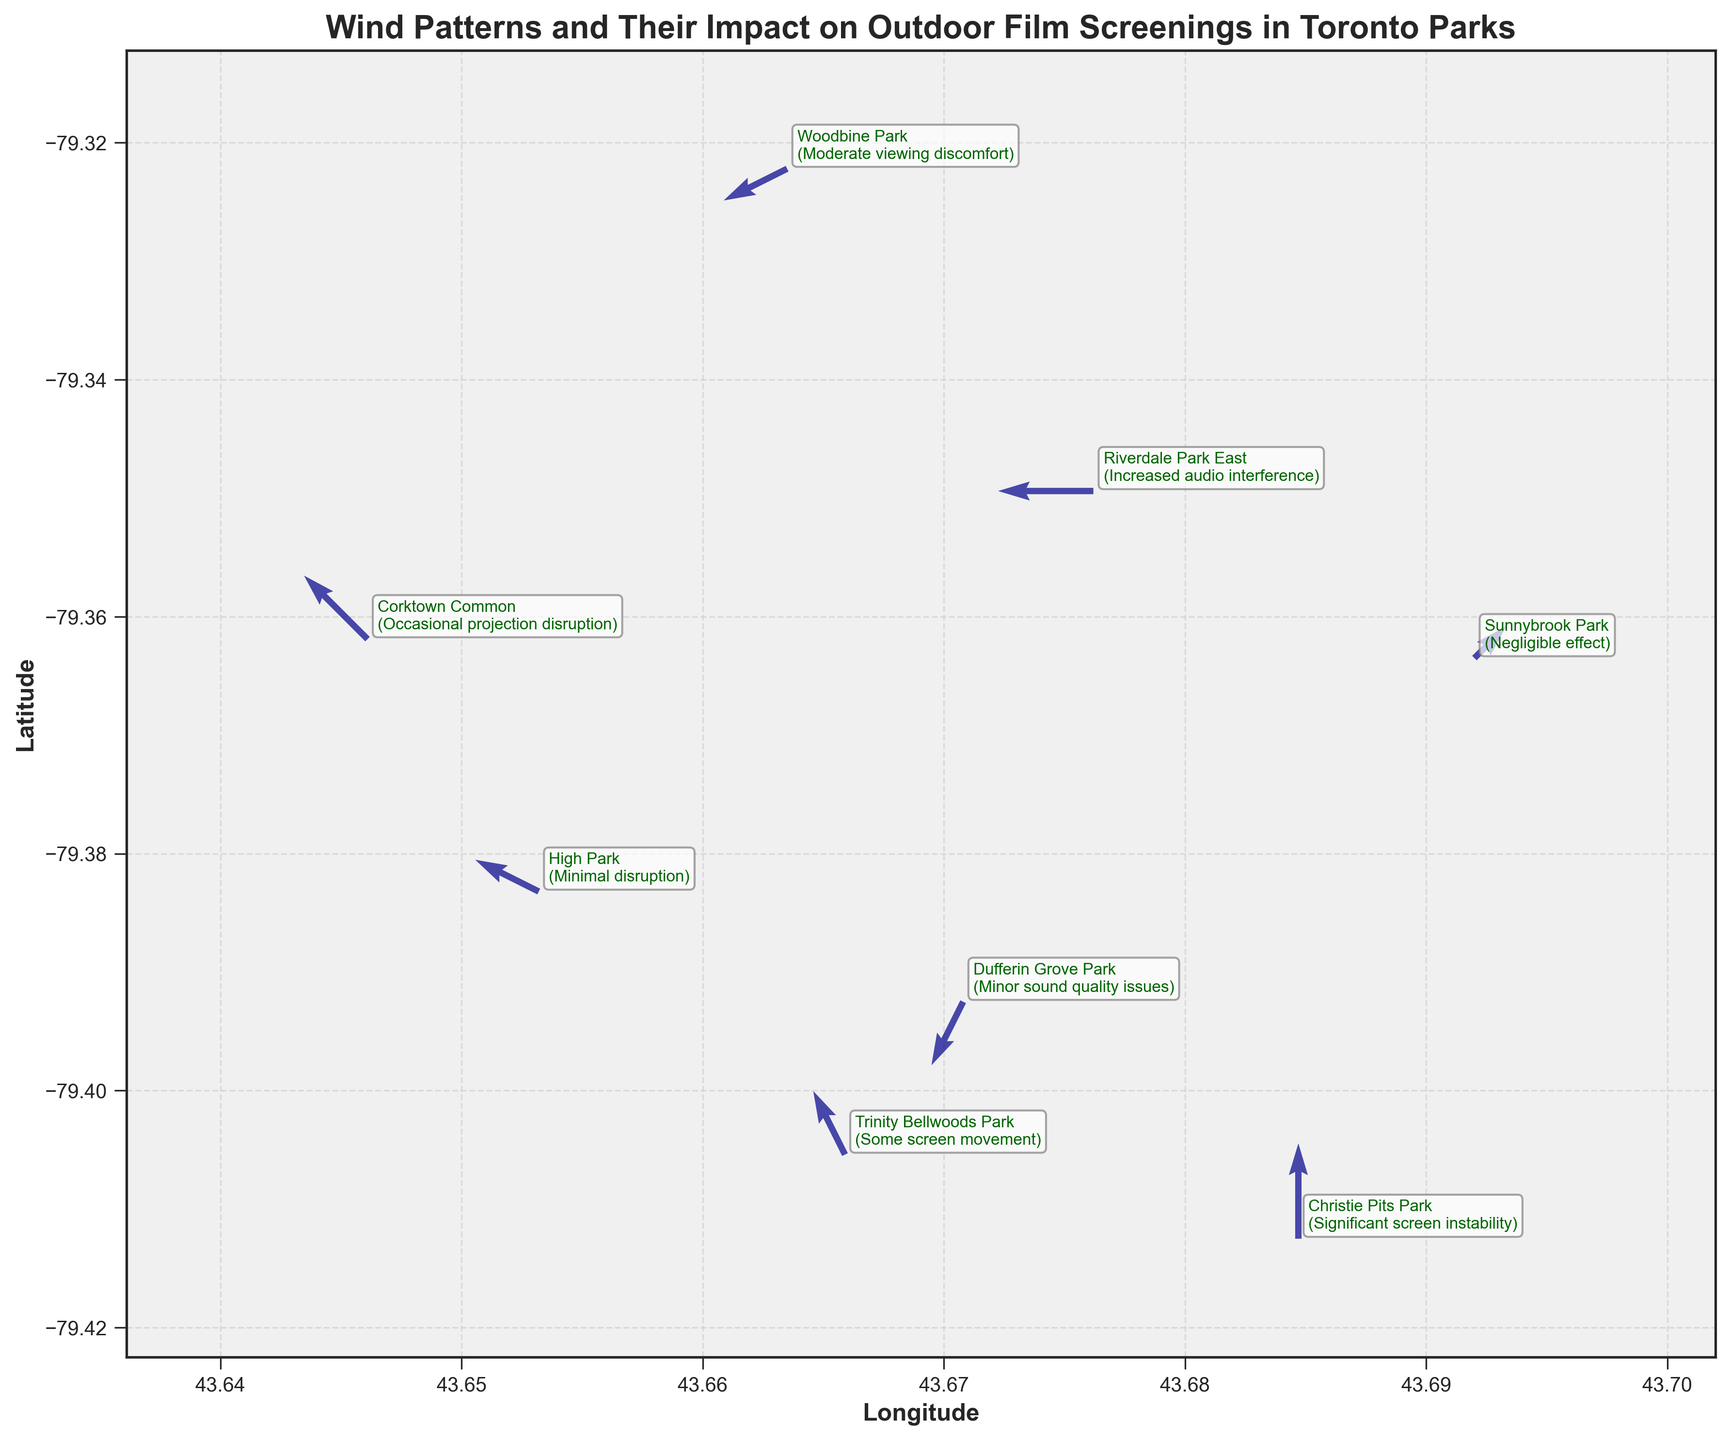What is the title of the plot? The title is located at the top center of the plot and typically conveys the main subject of the visualization. The title of this plot is "Wind Patterns and Their Impact on Outdoor Film Screenings in Toronto Parks".
Answer: Wind Patterns and Their Impact on Outdoor Film Screenings in Toronto Parks What are the labels of the x-axis and y-axis? The x-axis and y-axis labels are clearly annotated on the plot. The x-axis is labeled "Longitude" and the y-axis is labeled "Latitude".
Answer: Longitude, Latitude Which park has the most significant screen instability? The plot annotates the names of the parks along with their impacts. The park annotation showing "Significant screen instability" is Christie Pits Park, indicating it is the one with the most significant screen instability.
Answer: Christie Pits Park How many parks are indicated to have wind-related effects? By counting the number of annotations on the plot, we can see that there are eight parks listed, each with a description of wind-related effects.
Answer: 8 Which parks experience some screen movement and minor sound quality issues, respectively? The annotations provide detailed effects experienced by each park. "Trinity Bellwoods Park" experiences some screen movement, and "Dufferin Grove Park" experiences minor sound quality issues.
Answer: Trinity Bellwoods Park, Dufferin Grove Park What is the average eastward (u) wind component for all parks? Sum the eastward wind components of all parks and divide by the number of parks. The u components are -2, -1, -3, -2, 0, -1, 1, -2. The sum is -10 and the number of parks is 8. The average is -10/8 = -1.25.
Answer: -1.25 Which park is located at the highest latitude (most northern)? Compare the latitude (y) values of all parks. The park with the highest latitude value is Sunnybrook Park with a latitude of 43.6920.
Answer: Sunnybrook Park Which park is located closest to the center of Toronto (43.6532, -79.3832)? Calculate the Euclidean distance from each park to the center of Toronto using the coordinates (x, y). The park with the shortest distance is High Park, which is actually located at the center itself with (43.6532, -79.3832).
Answer: High Park What is the general wind direction in Riverdale Park East? The wind vectors in the plot indicate the direction of the wind. For Riverdale Park East, the wind vector components are u = -3 and v = 0. This means the wind is blowing directly westward.
Answer: Westward What is the visual impact of wind in Corktown Common? The annotation next to Corktown Common states that the visual impact is "Occasional projection disruption". This indicates that the wind occasionally disrupts the projection.
Answer: Occasional projection disruption 